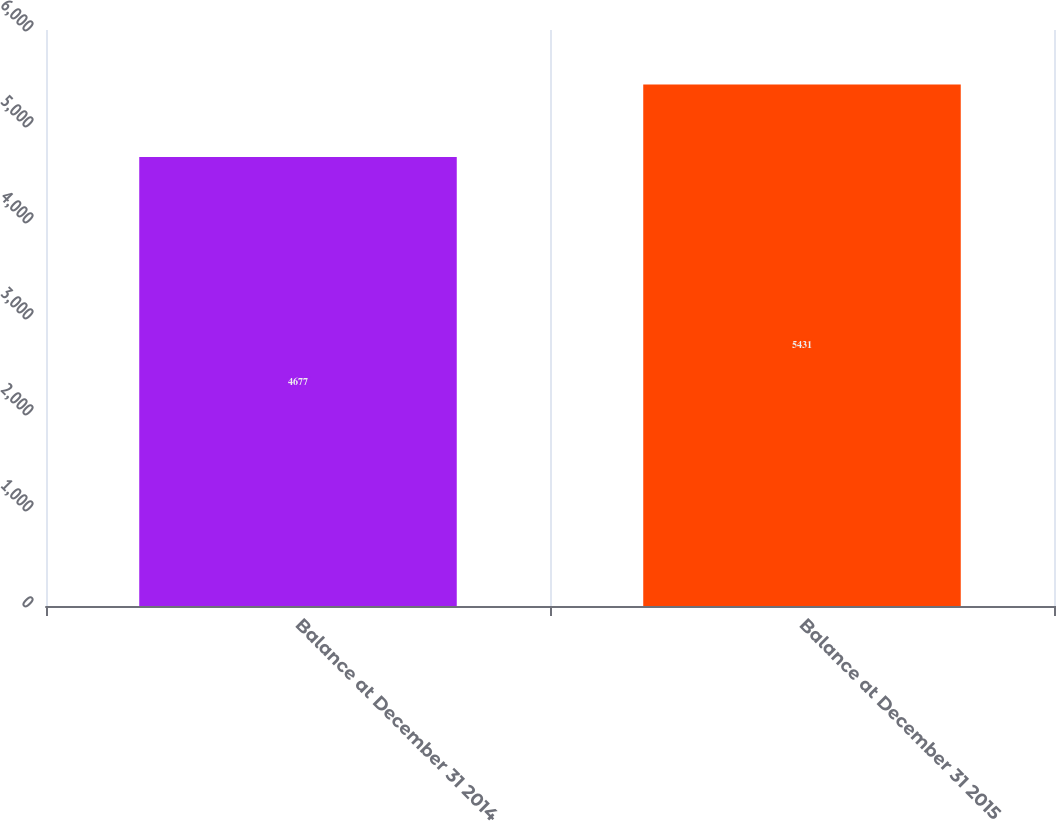Convert chart. <chart><loc_0><loc_0><loc_500><loc_500><bar_chart><fcel>Balance at December 31 2014<fcel>Balance at December 31 2015<nl><fcel>4677<fcel>5431<nl></chart> 